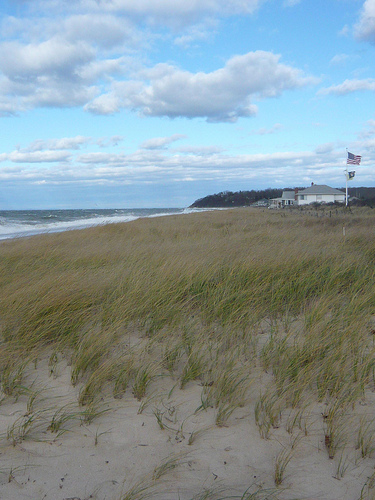<image>
Is the sky behind the building? No. The sky is not behind the building. From this viewpoint, the sky appears to be positioned elsewhere in the scene. 